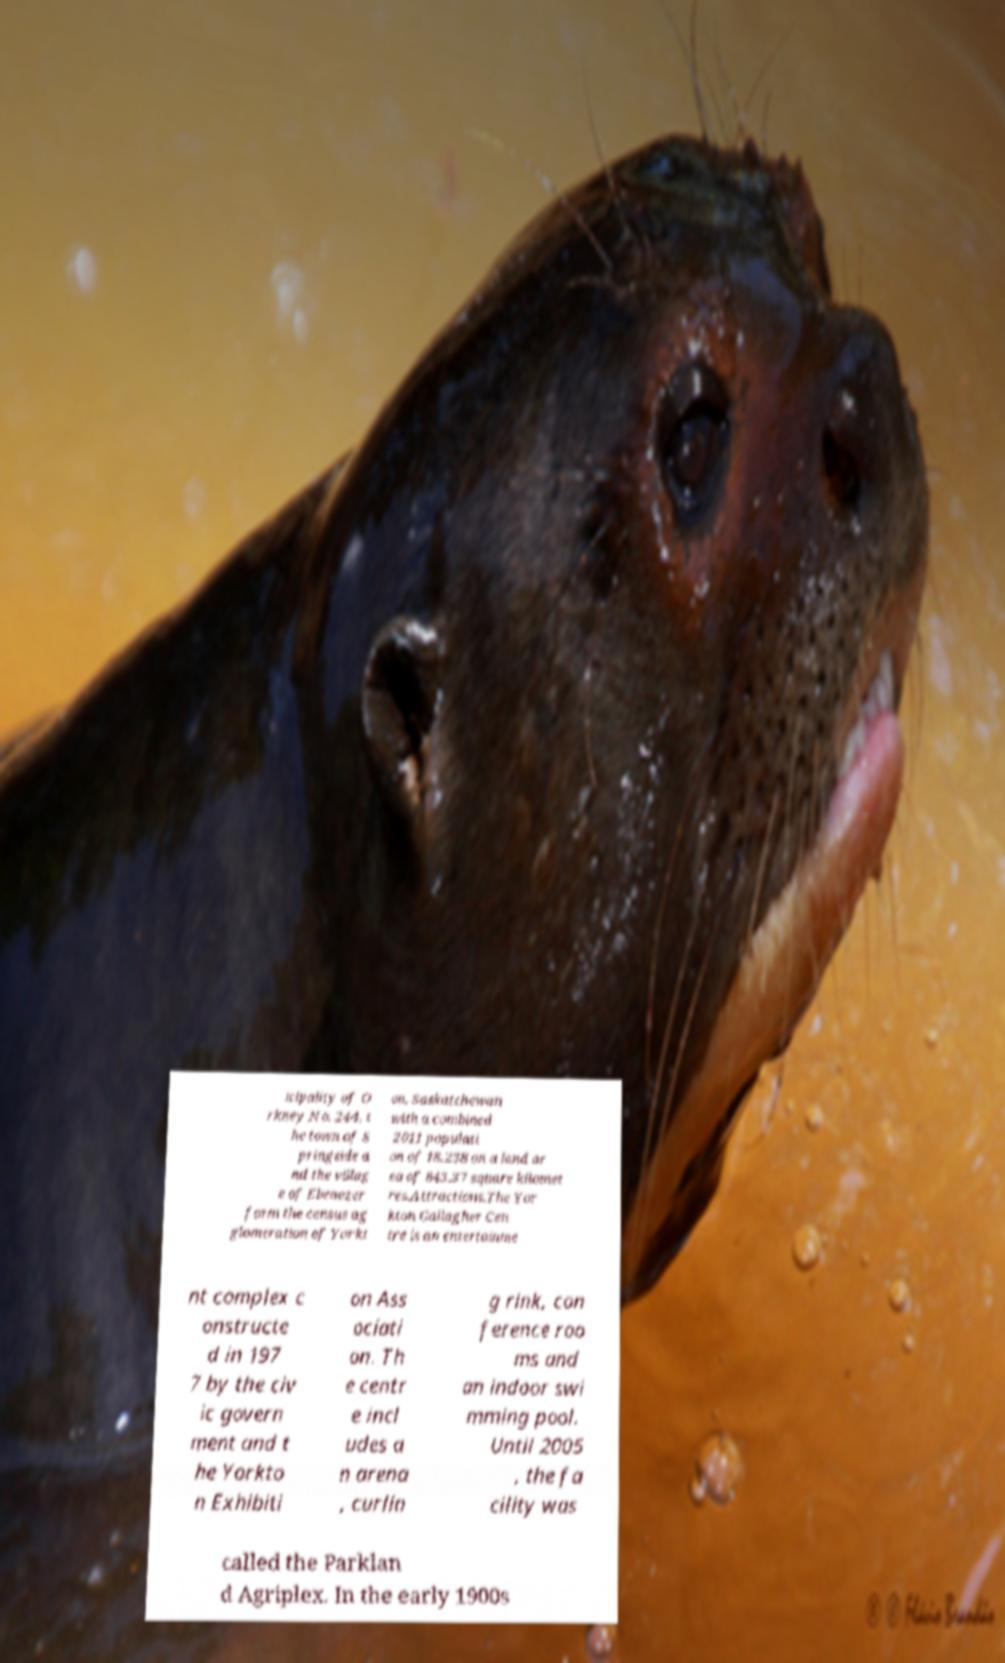Please identify and transcribe the text found in this image. icipality of O rkney No. 244, t he town of S pringside a nd the villag e of Ebenezer form the census ag glomeration of Yorkt on, Saskatchewan with a combined 2011 populati on of 18,238 on a land ar ea of 843.37 square kilomet res.Attractions.The Yor kton Gallagher Cen tre is an entertainme nt complex c onstructe d in 197 7 by the civ ic govern ment and t he Yorkto n Exhibiti on Ass ociati on. Th e centr e incl udes a n arena , curlin g rink, con ference roo ms and an indoor swi mming pool. Until 2005 , the fa cility was called the Parklan d Agriplex. In the early 1900s 